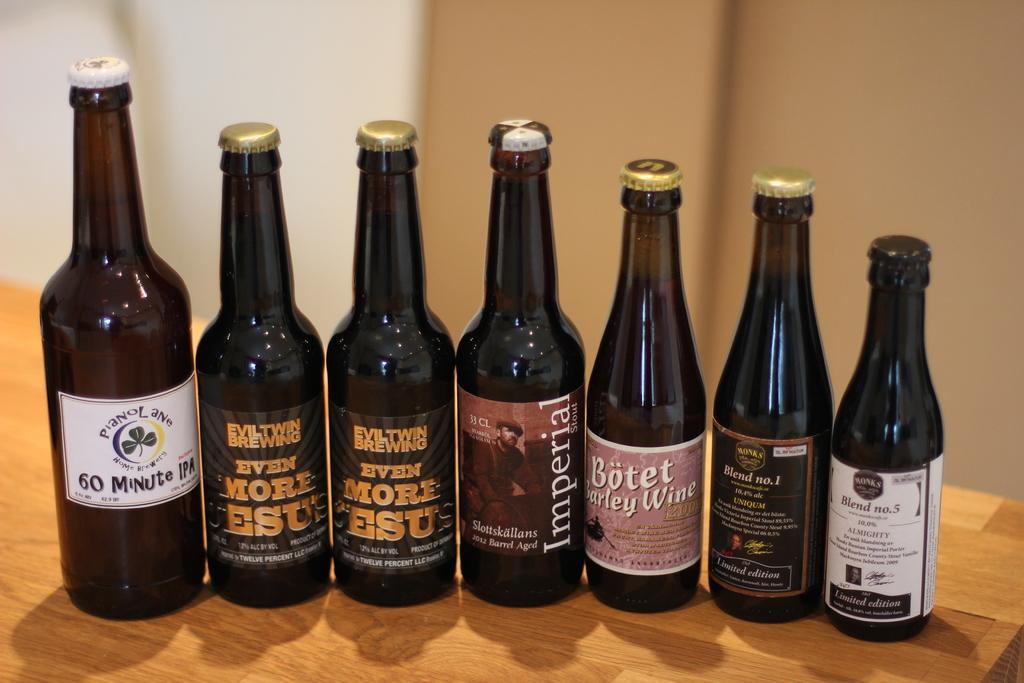Please provide a concise description of this image. In this picture I can see few bottles on the table and I can see a wall in the back. 